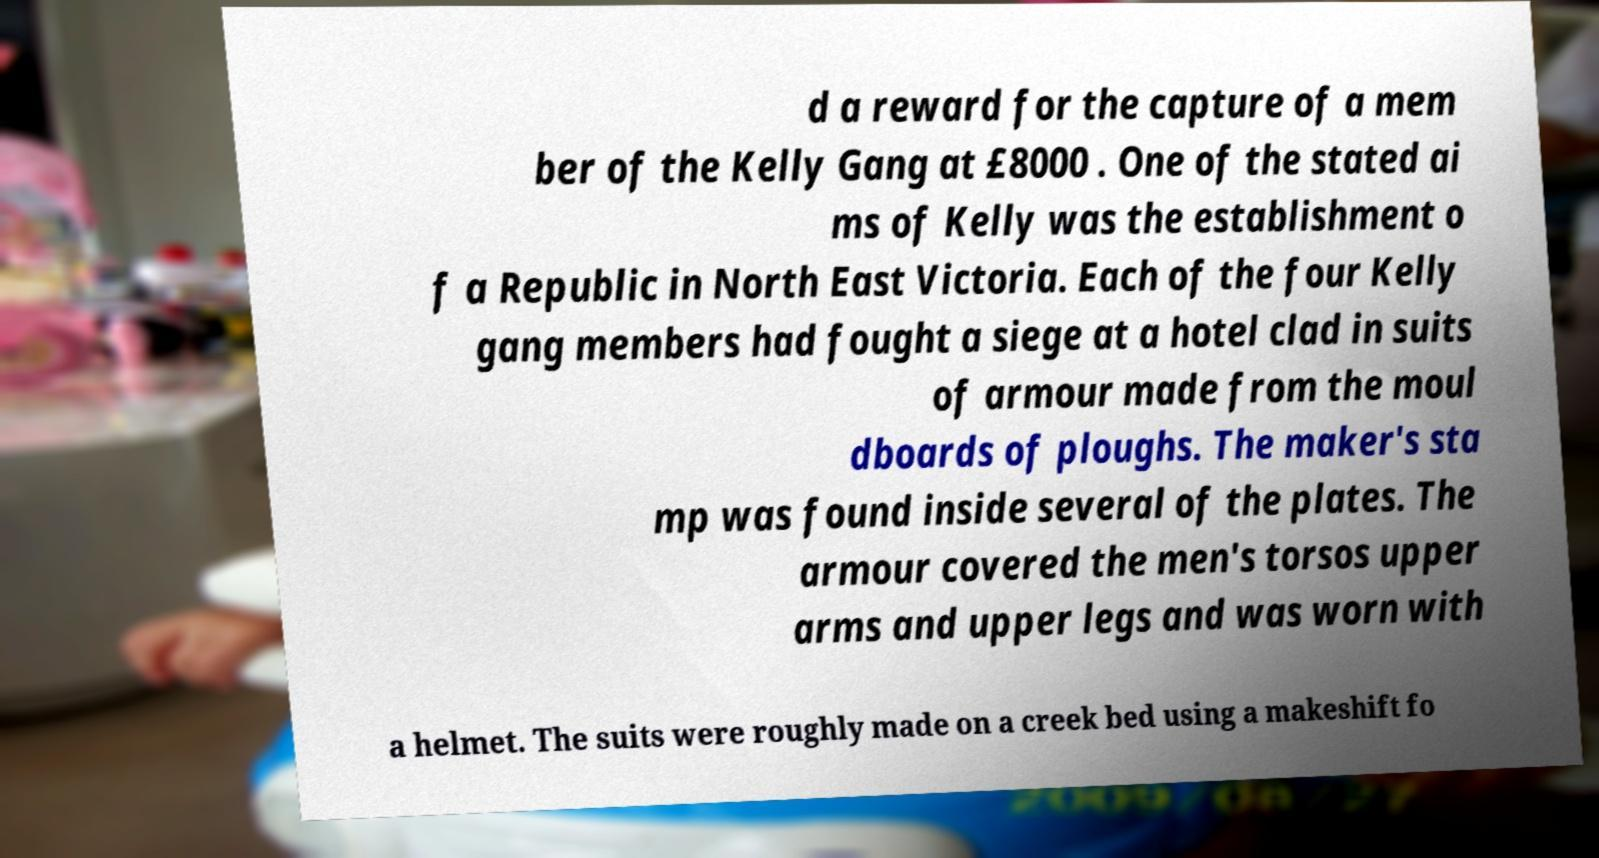Please identify and transcribe the text found in this image. d a reward for the capture of a mem ber of the Kelly Gang at £8000 . One of the stated ai ms of Kelly was the establishment o f a Republic in North East Victoria. Each of the four Kelly gang members had fought a siege at a hotel clad in suits of armour made from the moul dboards of ploughs. The maker's sta mp was found inside several of the plates. The armour covered the men's torsos upper arms and upper legs and was worn with a helmet. The suits were roughly made on a creek bed using a makeshift fo 